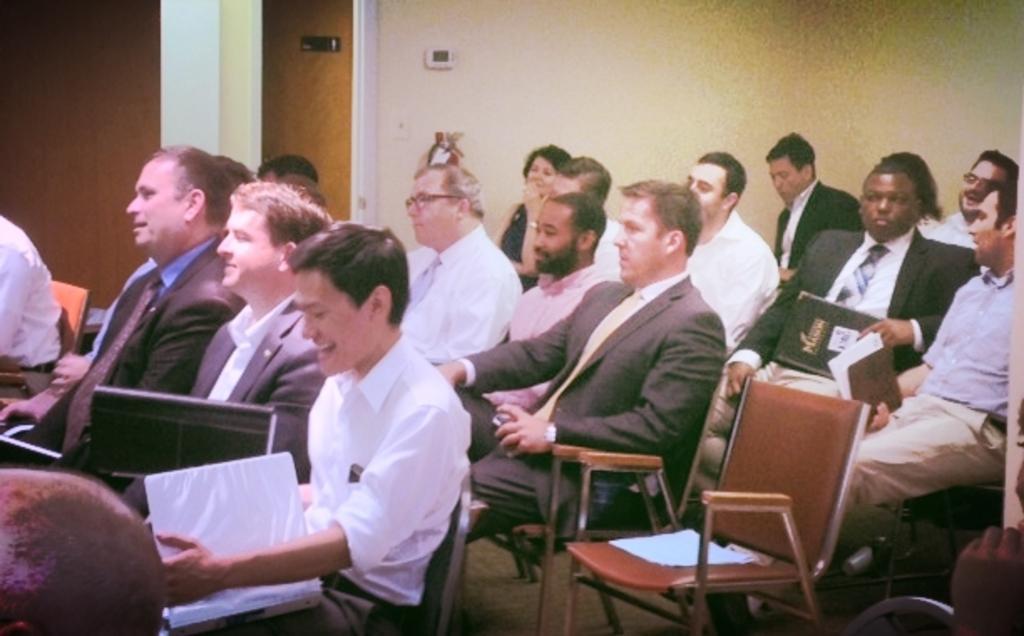Can you describe this image briefly? There are few people sitting on the chair and holding files in their hands. 